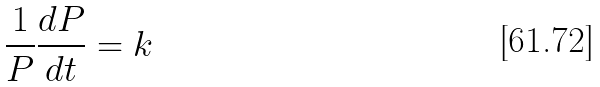<formula> <loc_0><loc_0><loc_500><loc_500>\frac { 1 } { P } \frac { d P } { d t } = k</formula> 